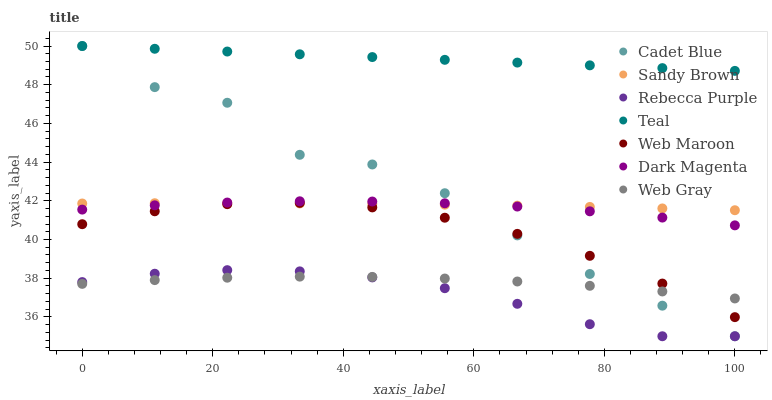Does Rebecca Purple have the minimum area under the curve?
Answer yes or no. Yes. Does Teal have the maximum area under the curve?
Answer yes or no. Yes. Does Dark Magenta have the minimum area under the curve?
Answer yes or no. No. Does Dark Magenta have the maximum area under the curve?
Answer yes or no. No. Is Teal the smoothest?
Answer yes or no. Yes. Is Cadet Blue the roughest?
Answer yes or no. Yes. Is Dark Magenta the smoothest?
Answer yes or no. No. Is Dark Magenta the roughest?
Answer yes or no. No. Does Cadet Blue have the lowest value?
Answer yes or no. Yes. Does Dark Magenta have the lowest value?
Answer yes or no. No. Does Teal have the highest value?
Answer yes or no. Yes. Does Dark Magenta have the highest value?
Answer yes or no. No. Is Web Gray less than Teal?
Answer yes or no. Yes. Is Web Maroon greater than Rebecca Purple?
Answer yes or no. Yes. Does Web Gray intersect Cadet Blue?
Answer yes or no. Yes. Is Web Gray less than Cadet Blue?
Answer yes or no. No. Is Web Gray greater than Cadet Blue?
Answer yes or no. No. Does Web Gray intersect Teal?
Answer yes or no. No. 